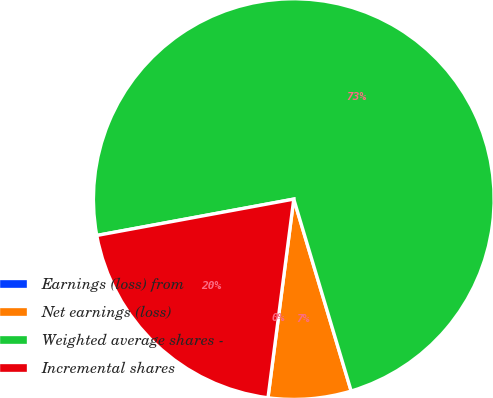Convert chart to OTSL. <chart><loc_0><loc_0><loc_500><loc_500><pie_chart><fcel>Earnings (loss) from<fcel>Net earnings (loss)<fcel>Weighted average shares -<fcel>Incremental shares<nl><fcel>0.0%<fcel>6.68%<fcel>73.28%<fcel>20.04%<nl></chart> 